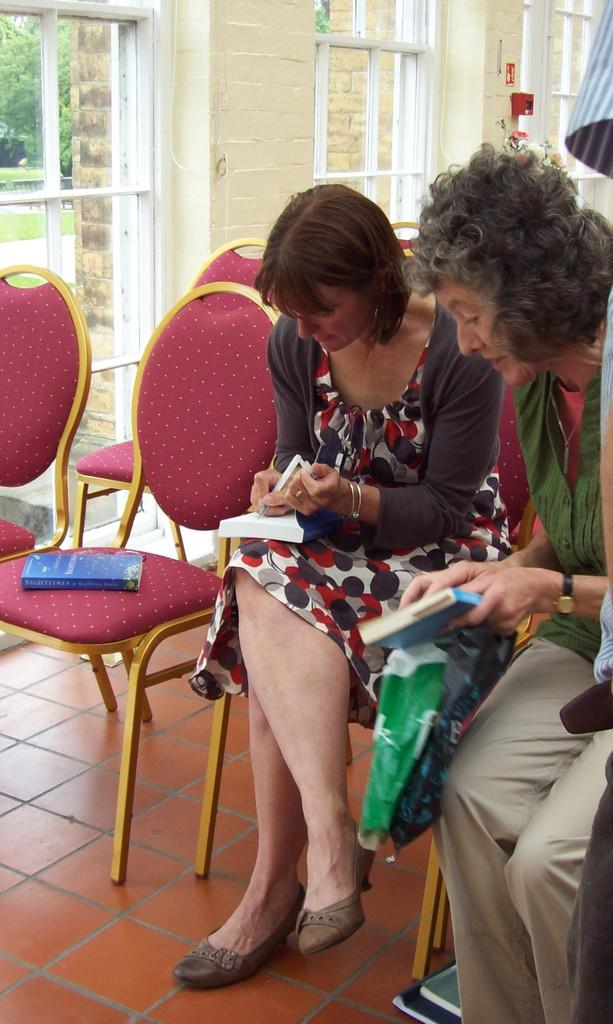How many people are sitting in the image? There are two persons sitting on chairs in the image. What can be seen in the background of the image? There is a wall in the background of the image. What is located at the top of the image? There are window glasses at the top of the image. What type of advice is being given by the person holding a rifle in the image? There is no person holding a rifle in the image, and therefore no advice is being given. 